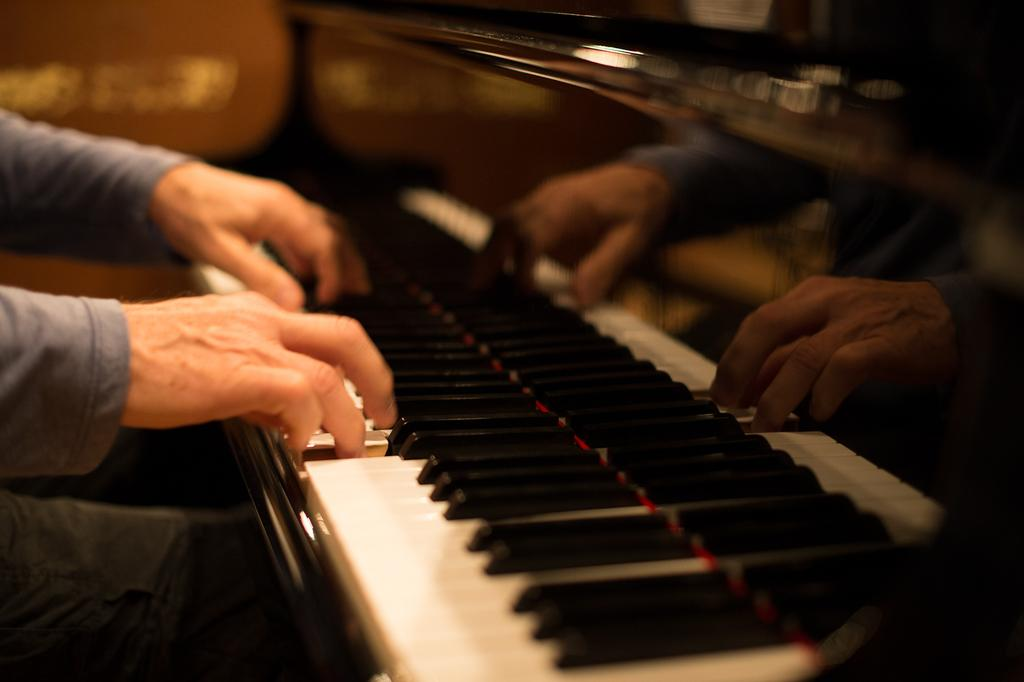What is the main activity being performed in the image? There is a person playing a piano in the image. Where is the person playing the piano located? The person is on the left side of the image. What is the reflection of the person doing in the image? There is a mirror image of the person on the right side of the image. What type of lunchroom can be seen in the image? There is no lunchroom present in the image. How many legs does the piano have in the image? The image does not show the legs of the piano, so it cannot be determined from the image. 